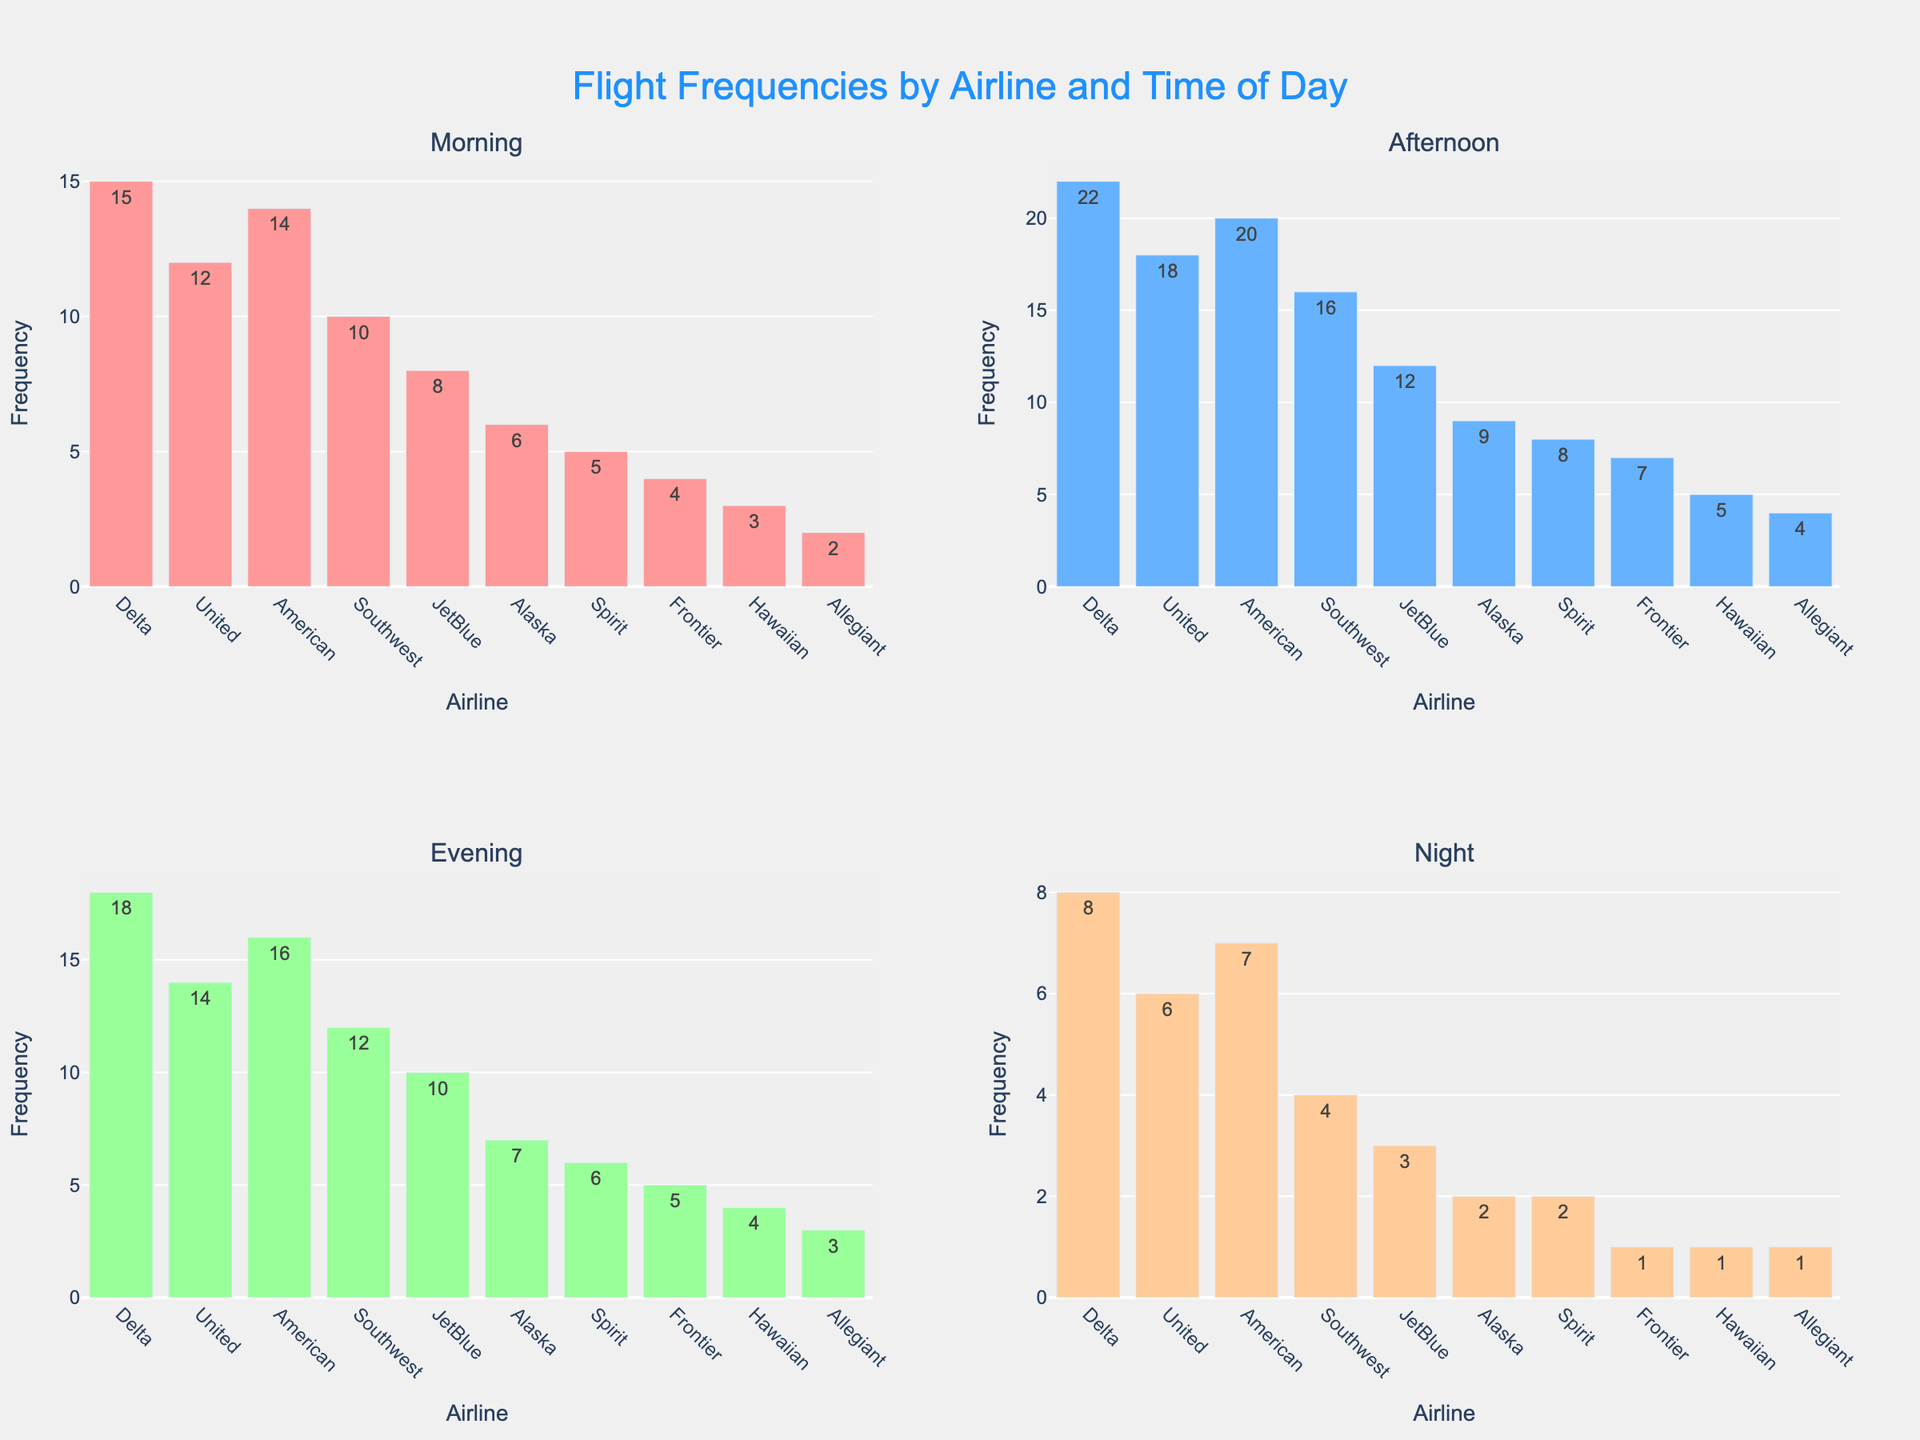What does the title of the figure indicate? The title of the figure provides an overview of what is being represented in the charts. It specifies that the figure shows the flight frequencies for different airlines across four times of the day: Morning, Afternoon, Evening, and Night.
Answer: Flight Frequencies by Airline and Time of Day How many times of the day are shown in the figure and what are they? By observing the subplot titles, we can see that there are four distinct time frames depicted: Morning, Afternoon, Evening, and Night.
Answer: Four: Morning, Afternoon, Evening, Night Which airline has the highest number of flights in the Morning? By looking at the Morning subplot, we observe that Delta has the highest bar, indicating the maximum number of flights.
Answer: Delta What are the total frequencies of flights for United Airlines during the Evening and Night combined? To find the total, sum the flight frequencies for United Airlines during the Evening (14 flights) and the Night (6 flights): 14 + 6 = 20.
Answer: 20 Which airline has the fewest flights in the Night? By examining the height of the bars in the Night subplot, we note that Frontier, Hawaiian, and Allegiant each have a single flight, the smallest value among all airlines.
Answer: Frontier, Hawaiian, Allegiant How many flights does Southwest Airlines have during Afternoon and Morning combined? We need to sum the frequency of flights for Southwest Airlines during the Afternoon (16 flights) and Morning (10 flights): 16 + 10 = 26.
Answer: 26 Which time of the day shows the most variability in flight frequencies across all airlines? Looking at all four subplots, the Afternoon subplot has the widest range of heights for the bars, indicating higher variability from 4 (Allegiant) to 22 (Delta).
Answer: Afternoon Rank the airlines by the number of flights in the Evening from most to least. By examining the Evening subplot and comparing bar heights, we can rank the airlines: Delta (18), American (16), United (14), Southwest (12), JetBlue (10), Alaska (7), Spirit (6), Frontier (5), Hawaiian (4), Allegiant (3).
Answer: Delta, American, United, Southwest, JetBlue, Alaska, Spirit, Frontier, Hawaiian, Allegiant Which time of day is least busy for JetBlue? By comparing the heights of the JetBlue bars across all four subplots, it is clear that Night has the smallest bar with 3 flights.
Answer: Night 